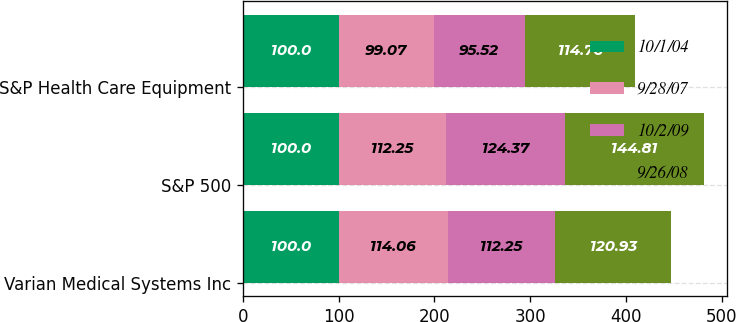Convert chart to OTSL. <chart><loc_0><loc_0><loc_500><loc_500><stacked_bar_chart><ecel><fcel>Varian Medical Systems Inc<fcel>S&P 500<fcel>S&P Health Care Equipment<nl><fcel>10/1/04<fcel>100<fcel>100<fcel>100<nl><fcel>9/28/07<fcel>114.06<fcel>112.25<fcel>99.07<nl><fcel>10/2/09<fcel>112.25<fcel>124.37<fcel>95.52<nl><fcel>9/26/08<fcel>120.93<fcel>144.81<fcel>114.76<nl></chart> 